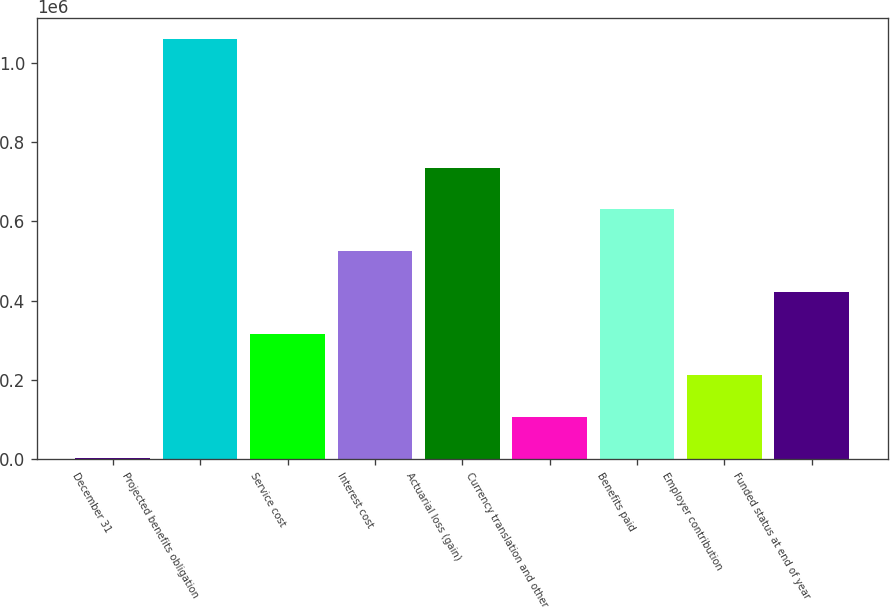Convert chart to OTSL. <chart><loc_0><loc_0><loc_500><loc_500><bar_chart><fcel>December 31<fcel>Projected benefits obligation<fcel>Service cost<fcel>Interest cost<fcel>Actuarial loss (gain)<fcel>Currency translation and other<fcel>Benefits paid<fcel>Employer contribution<fcel>Funded status at end of year<nl><fcel>2010<fcel>1.06231e+06<fcel>316337<fcel>525888<fcel>735439<fcel>106786<fcel>630664<fcel>211561<fcel>421112<nl></chart> 